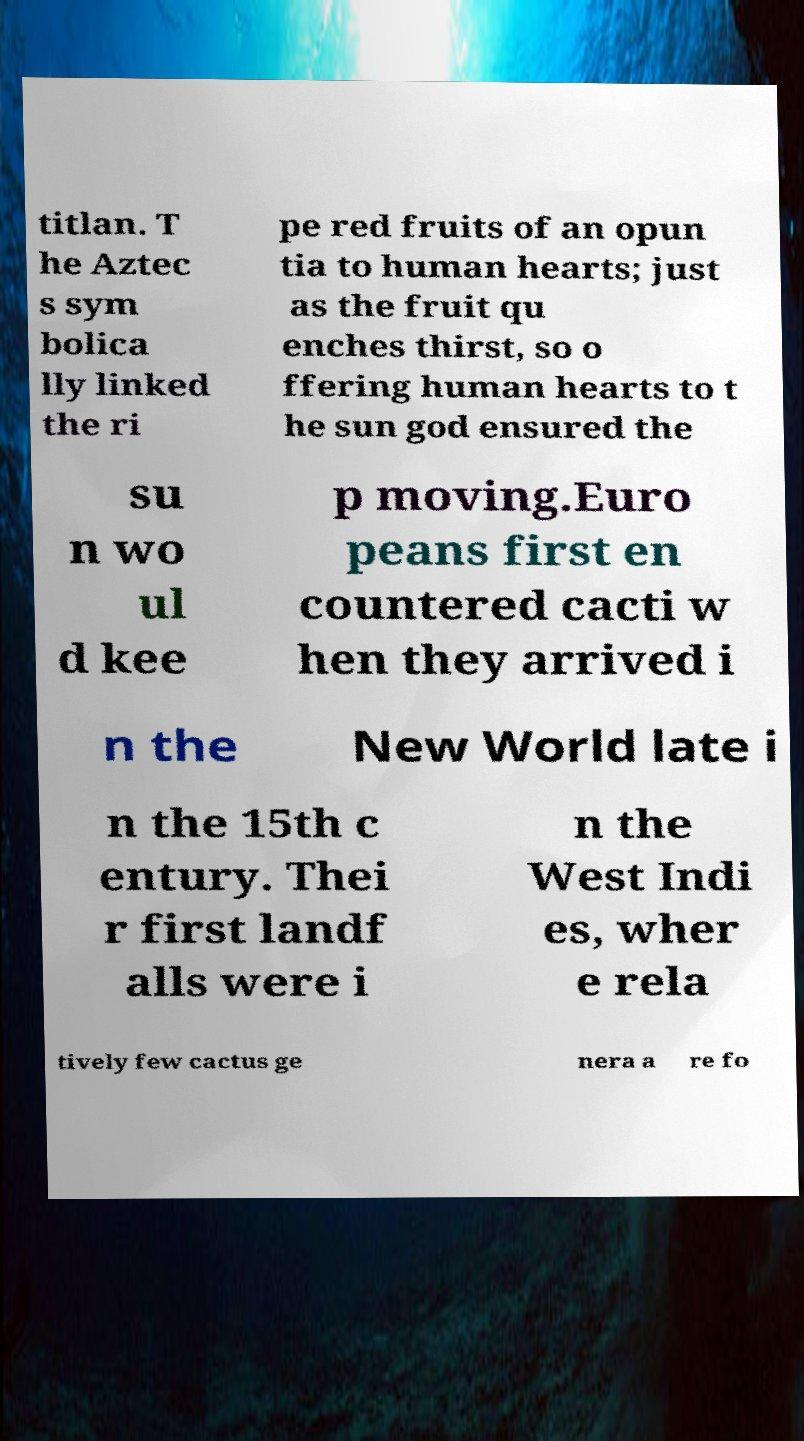For documentation purposes, I need the text within this image transcribed. Could you provide that? titlan. T he Aztec s sym bolica lly linked the ri pe red fruits of an opun tia to human hearts; just as the fruit qu enches thirst, so o ffering human hearts to t he sun god ensured the su n wo ul d kee p moving.Euro peans first en countered cacti w hen they arrived i n the New World late i n the 15th c entury. Thei r first landf alls were i n the West Indi es, wher e rela tively few cactus ge nera a re fo 